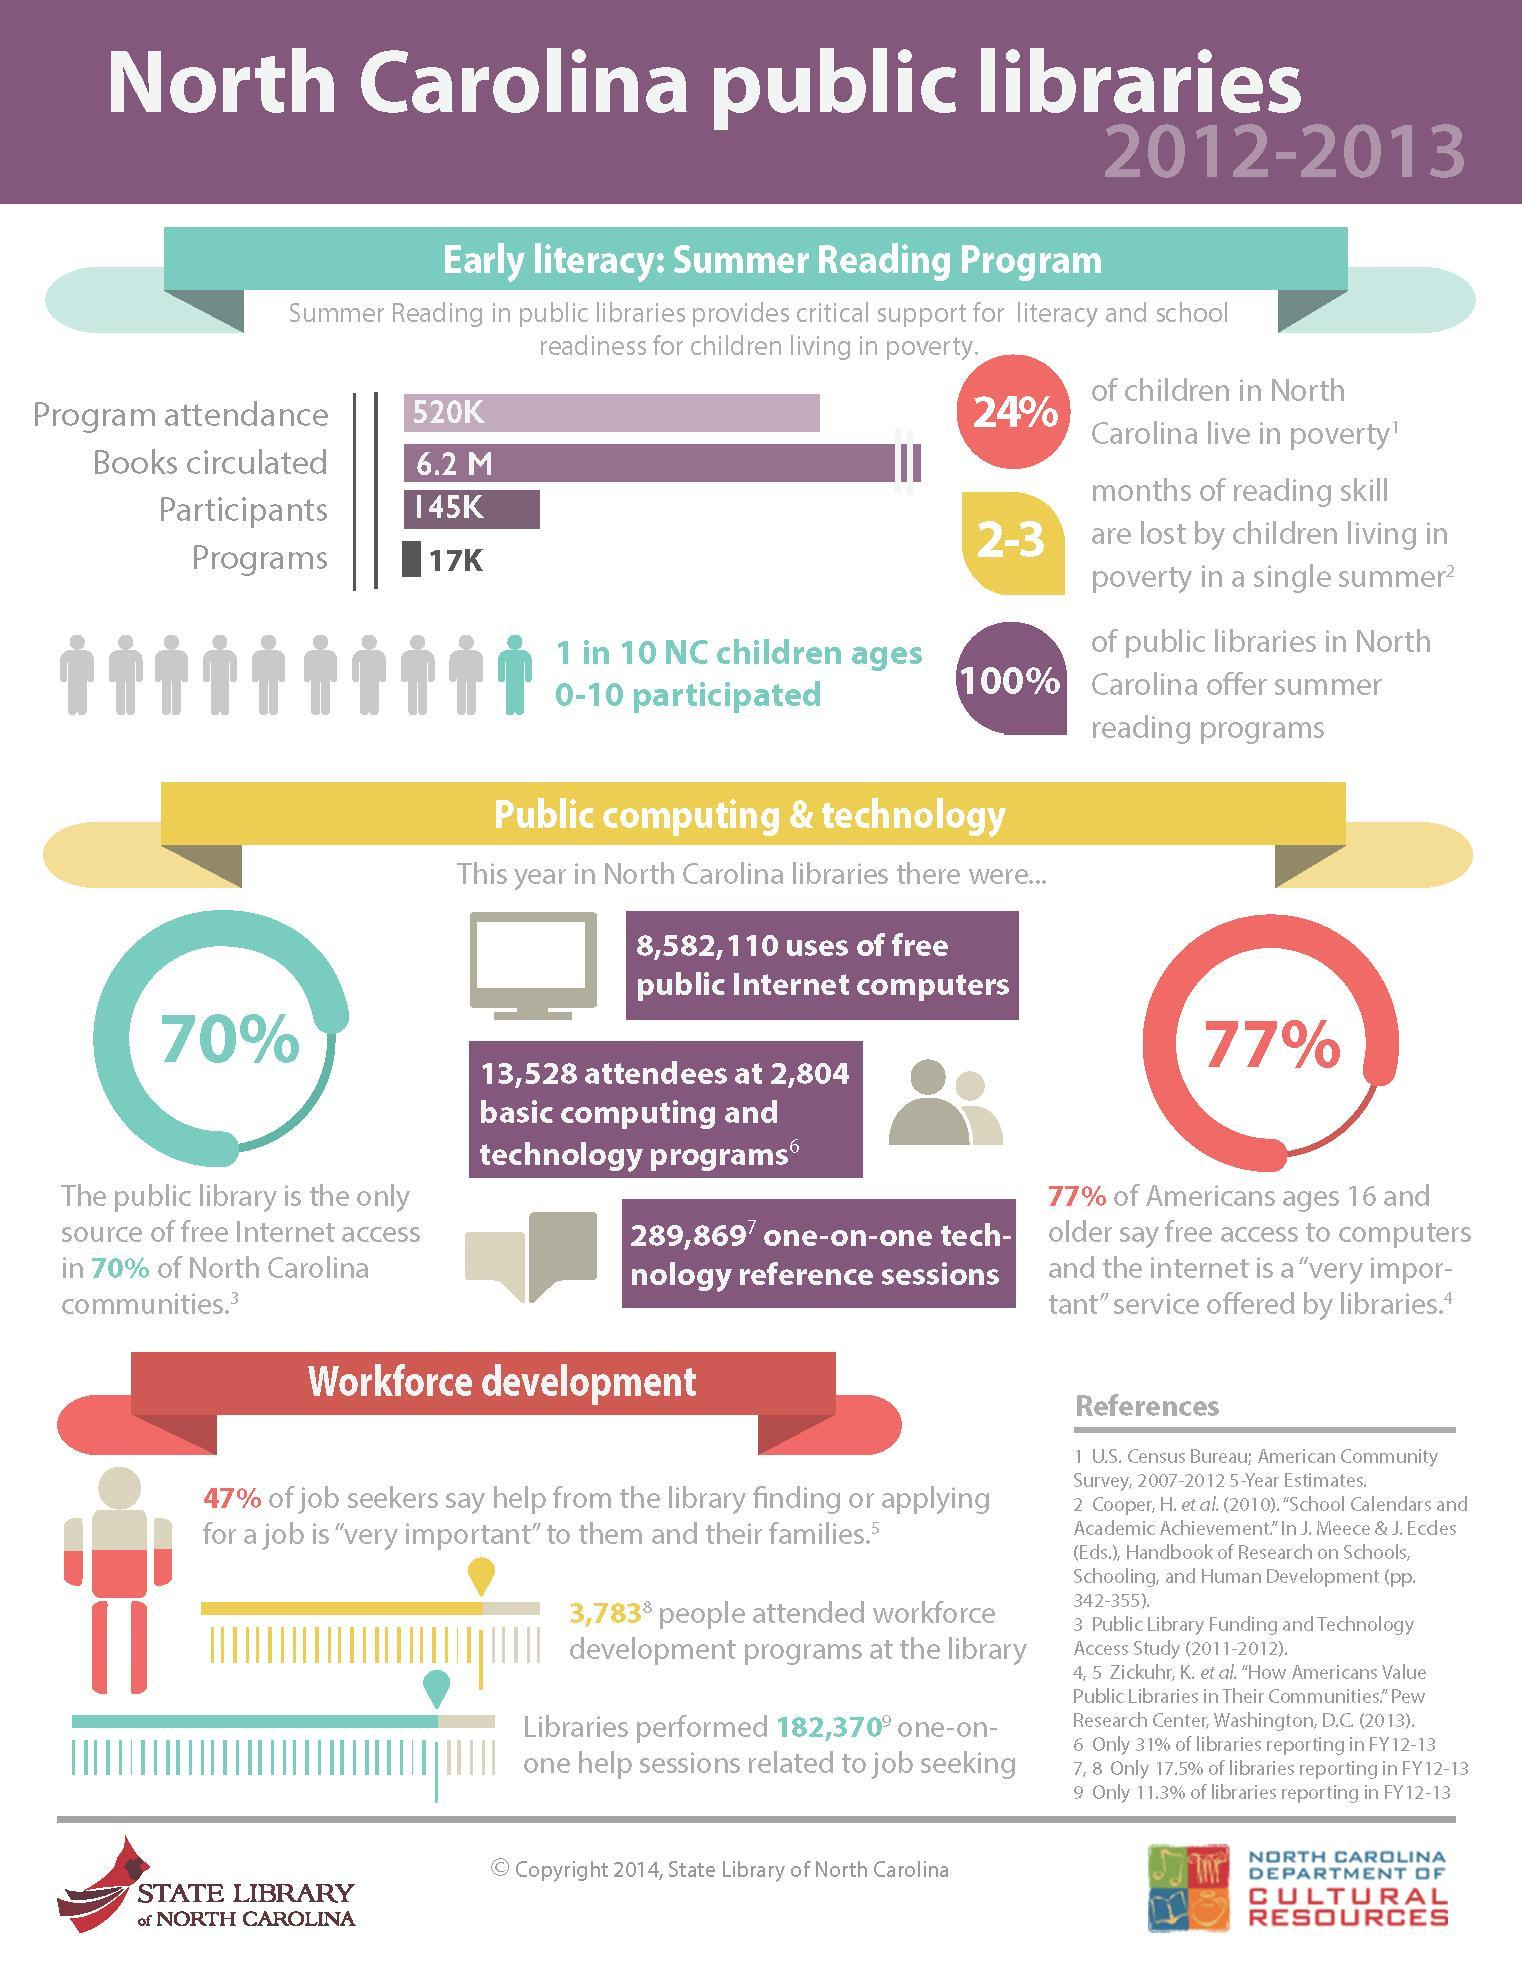What functions as the sole source of free internet access for majority of communities in North Carolina?
Answer the question with a short phrase. the public library What percent of people felt that free access to computer and internet was very important service by libraries? 77% How many technology reference sessions were facilitated by public libraries? 289,869 